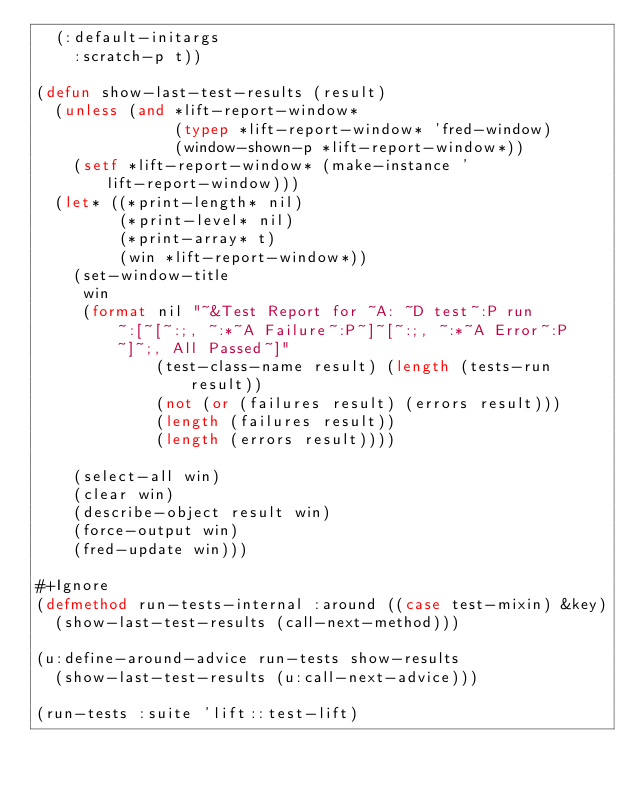<code> <loc_0><loc_0><loc_500><loc_500><_Lisp_>  (:default-initargs 
    :scratch-p t))

(defun show-last-test-results (result)  
  (unless (and *lift-report-window*
               (typep *lift-report-window* 'fred-window)
               (window-shown-p *lift-report-window*))
    (setf *lift-report-window* (make-instance 'lift-report-window)))
  (let* ((*print-length* nil)
         (*print-level* nil)
         (*print-array* t) 
         (win *lift-report-window*))
    (set-window-title 
     win 
     (format nil "~&Test Report for ~A: ~D test~:P run~:[~[~:;, ~:*~A Failure~:P~]~[~:;, ~:*~A Error~:P~]~;, All Passed~]" 
             (test-class-name result) (length (tests-run result))
             (not (or (failures result) (errors result)))
             (length (failures result))
             (length (errors result))))
     
    (select-all win)
    (clear win)
    (describe-object result win)
    (force-output win)
    (fred-update win)))

#+Ignore
(defmethod run-tests-internal :around ((case test-mixin) &key)
  (show-last-test-results (call-next-method)))

(u:define-around-advice run-tests show-results
  (show-last-test-results (u:call-next-advice)))
  
(run-tests :suite 'lift::test-lift)</code> 